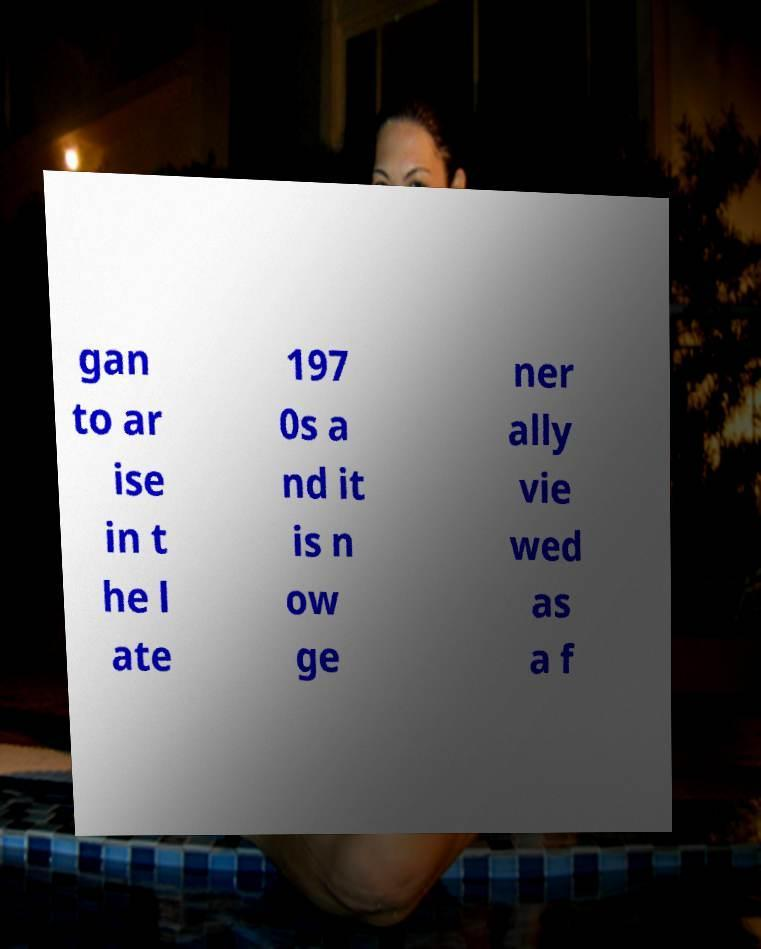Can you read and provide the text displayed in the image?This photo seems to have some interesting text. Can you extract and type it out for me? gan to ar ise in t he l ate 197 0s a nd it is n ow ge ner ally vie wed as a f 